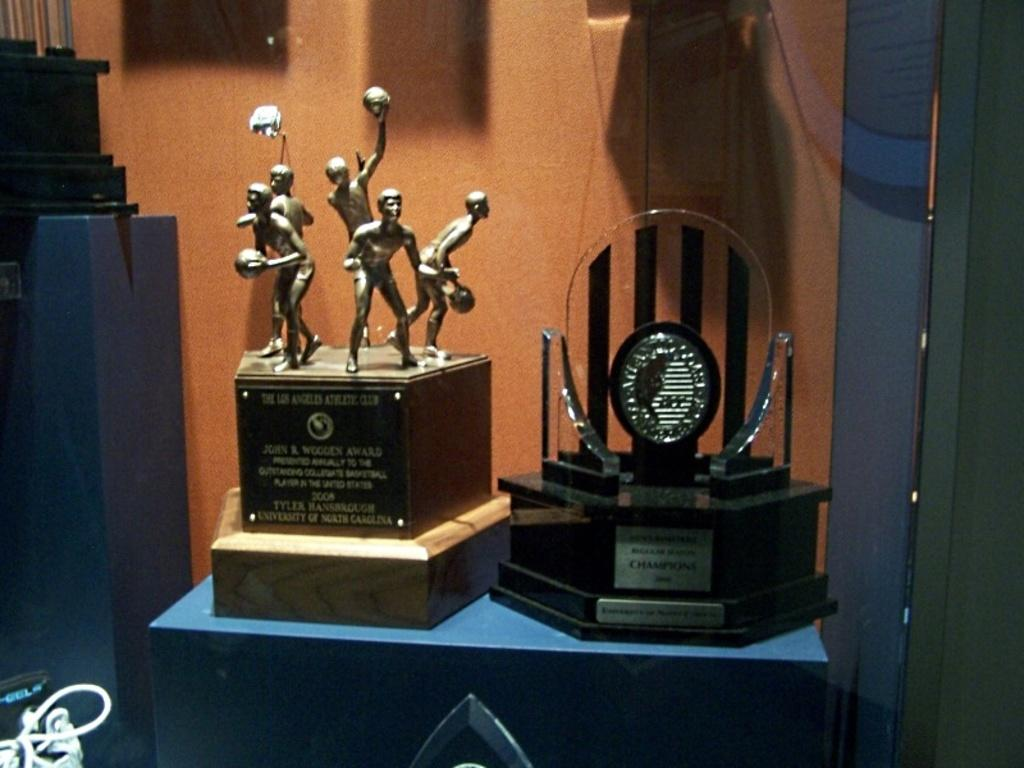What is placed on the table in the image? There are mementos placed on a table. Can you describe the object on the surface of the table? There is an object on the surface of the table, but the specific details are not provided. What can be seen in the background of the image? There is a wall in the image. Are there any additional elements visible in the image? Yes, there are wires visible in the image. What type of stone is the stranger holding in the image? There is no stranger or stone present in the image. 